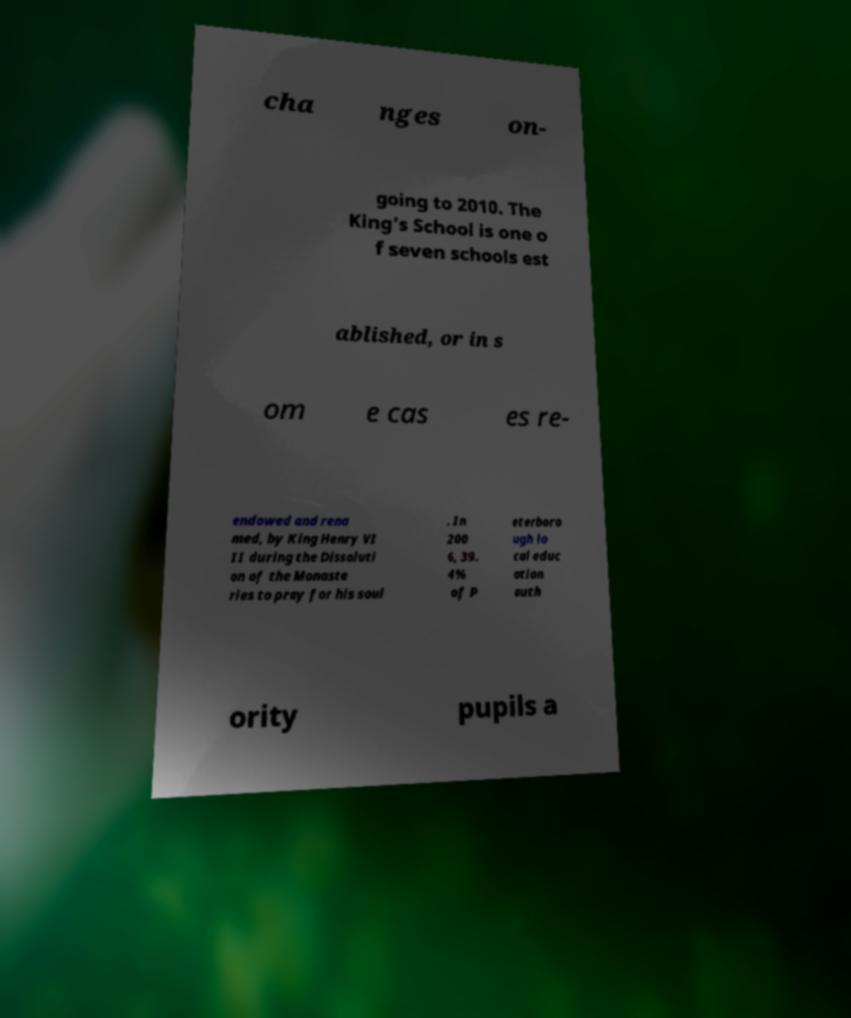Can you accurately transcribe the text from the provided image for me? cha nges on- going to 2010. The King's School is one o f seven schools est ablished, or in s om e cas es re- endowed and rena med, by King Henry VI II during the Dissoluti on of the Monaste ries to pray for his soul . In 200 6, 39. 4% of P eterboro ugh lo cal educ ation auth ority pupils a 